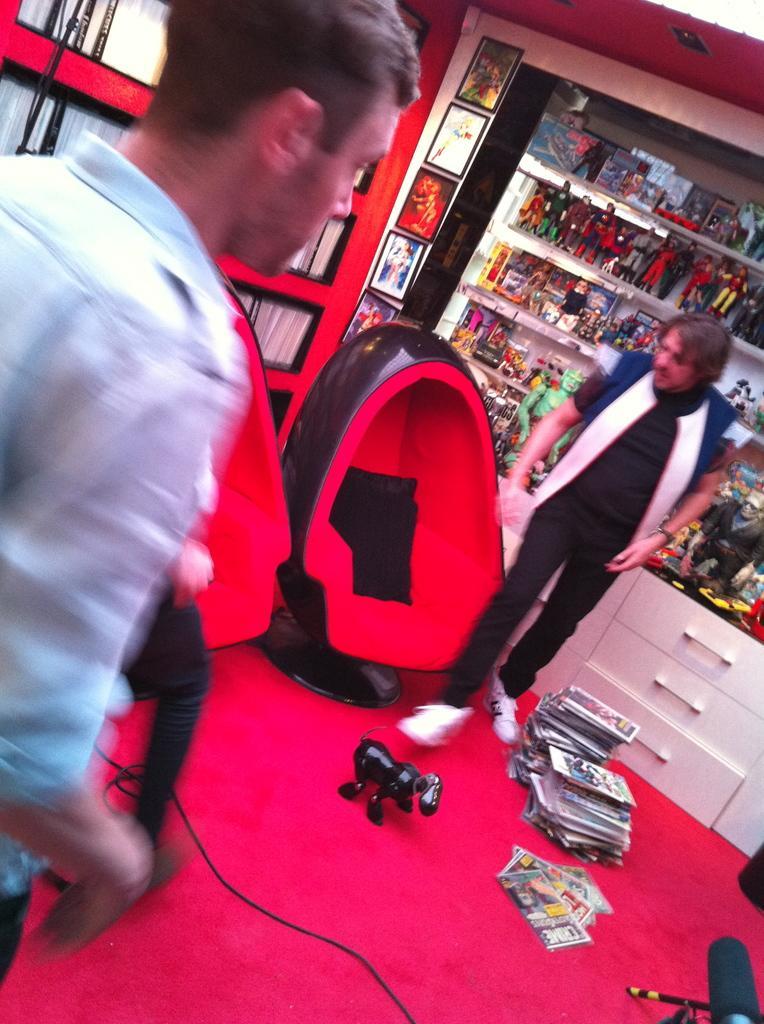How would you summarize this image in a sentence or two? On the left side of the image there is a person, in front of the person there is another person's leg, beside him there are two empty chairs, beside the chairs there is another person standing, in front of him on the floor there are some objects, behind him there are cupboards and there are some objects on the shelves and there are photo frames on the wall. 